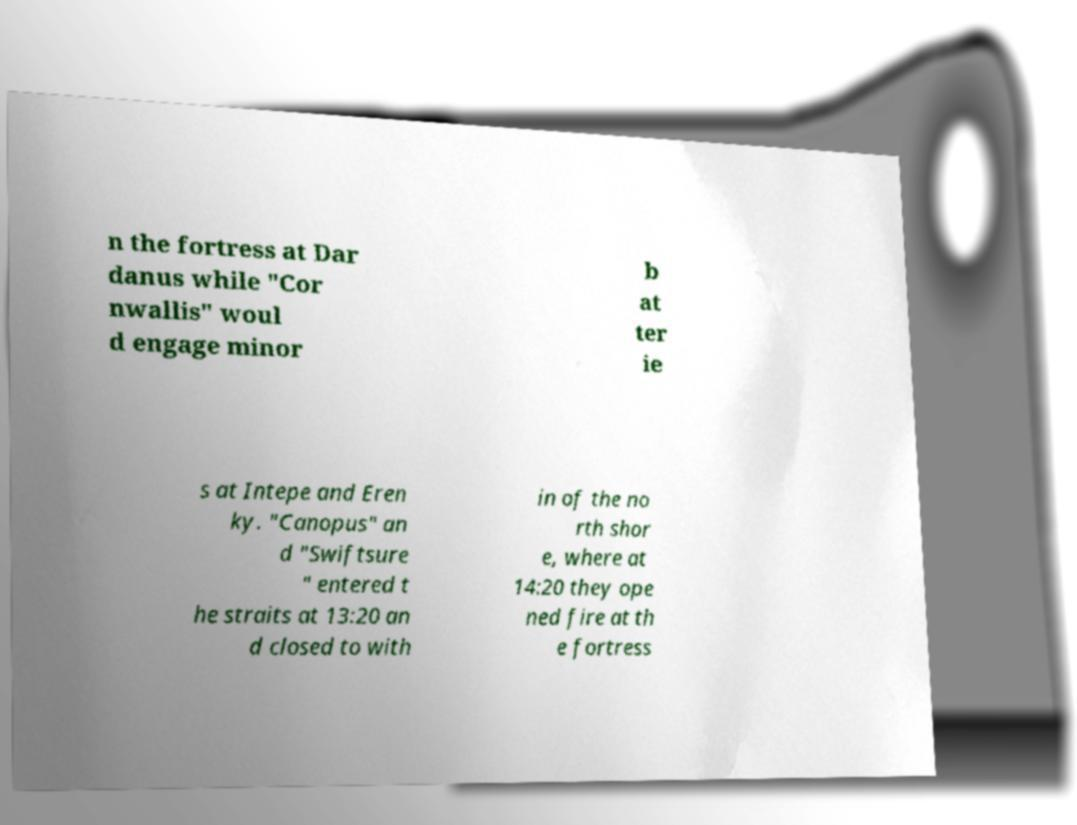Could you extract and type out the text from this image? n the fortress at Dar danus while "Cor nwallis" woul d engage minor b at ter ie s at Intepe and Eren ky. "Canopus" an d "Swiftsure " entered t he straits at 13:20 an d closed to with in of the no rth shor e, where at 14:20 they ope ned fire at th e fortress 